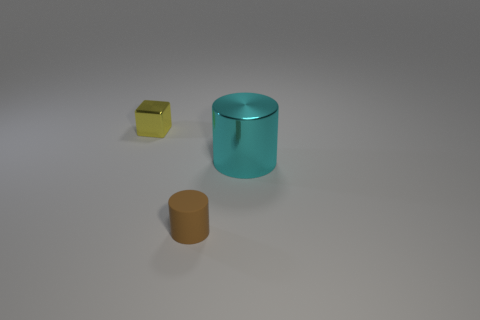Are there any other things that have the same size as the cyan metallic cylinder?
Give a very brief answer. No. Is there anything else that is the same shape as the yellow shiny thing?
Keep it short and to the point. No. What number of other things have the same shape as the small brown object?
Make the answer very short. 1. There is a yellow cube that is made of the same material as the big cyan cylinder; what is its size?
Ensure brevity in your answer.  Small. Are there the same number of tiny brown cylinders that are right of the yellow metallic block and large cyan shiny cylinders?
Your response must be concise. Yes. Do the shiny object that is to the right of the small yellow shiny thing and the shiny object that is behind the large cyan cylinder have the same shape?
Provide a short and direct response. No. There is a small brown thing that is the same shape as the big cyan object; what is it made of?
Your response must be concise. Rubber. What color is the object that is right of the metallic cube and on the left side of the big cyan metallic cylinder?
Your response must be concise. Brown. Is there a yellow metallic object that is behind the metal object on the right side of the tiny object in front of the metal cylinder?
Keep it short and to the point. Yes. What number of objects are large red matte balls or cyan things?
Offer a very short reply. 1. 